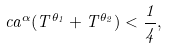<formula> <loc_0><loc_0><loc_500><loc_500>c a ^ { \alpha } ( T ^ { \theta _ { 1 } } + T ^ { \theta _ { 2 } } ) < \frac { 1 } { 4 } ,</formula> 